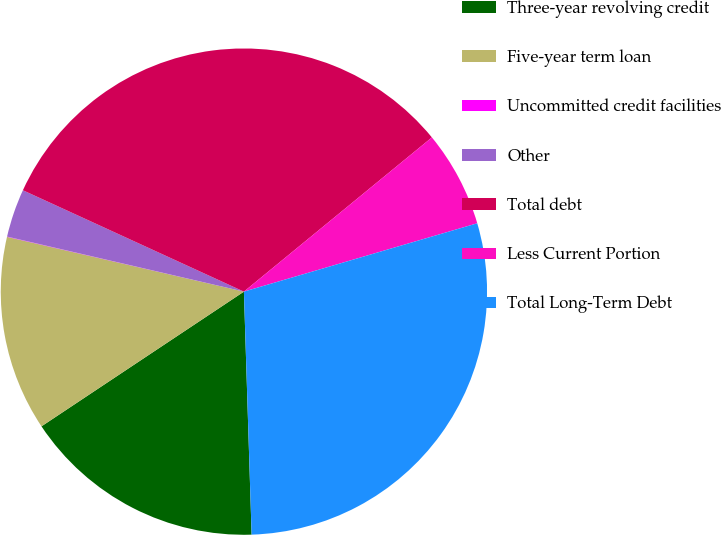<chart> <loc_0><loc_0><loc_500><loc_500><pie_chart><fcel>Three-year revolving credit<fcel>Five-year term loan<fcel>Uncommitted credit facilities<fcel>Other<fcel>Total debt<fcel>Less Current Portion<fcel>Total Long-Term Debt<nl><fcel>16.16%<fcel>12.96%<fcel>0.02%<fcel>3.21%<fcel>32.22%<fcel>6.4%<fcel>29.03%<nl></chart> 